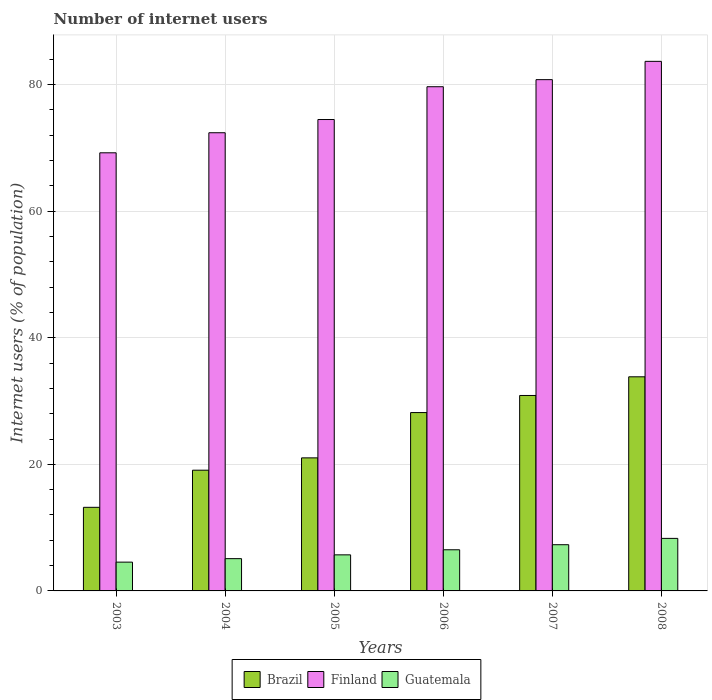How many groups of bars are there?
Your response must be concise. 6. Are the number of bars per tick equal to the number of legend labels?
Give a very brief answer. Yes. How many bars are there on the 5th tick from the left?
Provide a succinct answer. 3. What is the label of the 2nd group of bars from the left?
Your response must be concise. 2004. What is the number of internet users in Finland in 2007?
Give a very brief answer. 80.78. Across all years, what is the maximum number of internet users in Brazil?
Ensure brevity in your answer.  33.83. Across all years, what is the minimum number of internet users in Guatemala?
Offer a very short reply. 4.55. In which year was the number of internet users in Finland maximum?
Keep it short and to the point. 2008. In which year was the number of internet users in Guatemala minimum?
Make the answer very short. 2003. What is the total number of internet users in Finland in the graph?
Your answer should be compact. 460.2. What is the difference between the number of internet users in Finland in 2004 and that in 2006?
Your answer should be compact. -7.27. What is the difference between the number of internet users in Finland in 2003 and the number of internet users in Brazil in 2006?
Your answer should be compact. 41.04. What is the average number of internet users in Guatemala per year?
Offer a very short reply. 6.24. In the year 2008, what is the difference between the number of internet users in Finland and number of internet users in Guatemala?
Provide a short and direct response. 75.37. What is the ratio of the number of internet users in Brazil in 2005 to that in 2008?
Your answer should be very brief. 0.62. Is the number of internet users in Brazil in 2004 less than that in 2008?
Make the answer very short. Yes. Is the difference between the number of internet users in Finland in 2005 and 2008 greater than the difference between the number of internet users in Guatemala in 2005 and 2008?
Provide a short and direct response. No. What is the difference between the highest and the second highest number of internet users in Guatemala?
Make the answer very short. 1. What is the difference between the highest and the lowest number of internet users in Brazil?
Provide a short and direct response. 20.62. In how many years, is the number of internet users in Guatemala greater than the average number of internet users in Guatemala taken over all years?
Your response must be concise. 3. What does the 1st bar from the right in 2005 represents?
Provide a short and direct response. Guatemala. Is it the case that in every year, the sum of the number of internet users in Guatemala and number of internet users in Brazil is greater than the number of internet users in Finland?
Keep it short and to the point. No. How many years are there in the graph?
Your response must be concise. 6. What is the difference between two consecutive major ticks on the Y-axis?
Provide a short and direct response. 20. Are the values on the major ticks of Y-axis written in scientific E-notation?
Provide a short and direct response. No. Does the graph contain any zero values?
Give a very brief answer. No. What is the title of the graph?
Your answer should be compact. Number of internet users. Does "Costa Rica" appear as one of the legend labels in the graph?
Ensure brevity in your answer.  No. What is the label or title of the X-axis?
Provide a short and direct response. Years. What is the label or title of the Y-axis?
Provide a succinct answer. Internet users (% of population). What is the Internet users (% of population) of Brazil in 2003?
Provide a short and direct response. 13.21. What is the Internet users (% of population) in Finland in 2003?
Provide a short and direct response. 69.22. What is the Internet users (% of population) of Guatemala in 2003?
Provide a succinct answer. 4.55. What is the Internet users (% of population) in Brazil in 2004?
Keep it short and to the point. 19.07. What is the Internet users (% of population) in Finland in 2004?
Make the answer very short. 72.39. What is the Internet users (% of population) of Guatemala in 2004?
Your answer should be compact. 5.1. What is the Internet users (% of population) of Brazil in 2005?
Give a very brief answer. 21.02. What is the Internet users (% of population) in Finland in 2005?
Offer a very short reply. 74.48. What is the Internet users (% of population) in Guatemala in 2005?
Keep it short and to the point. 5.7. What is the Internet users (% of population) in Brazil in 2006?
Provide a succinct answer. 28.18. What is the Internet users (% of population) in Finland in 2006?
Ensure brevity in your answer.  79.66. What is the Internet users (% of population) of Brazil in 2007?
Make the answer very short. 30.88. What is the Internet users (% of population) of Finland in 2007?
Your answer should be very brief. 80.78. What is the Internet users (% of population) of Brazil in 2008?
Provide a succinct answer. 33.83. What is the Internet users (% of population) in Finland in 2008?
Keep it short and to the point. 83.67. What is the Internet users (% of population) of Guatemala in 2008?
Your response must be concise. 8.3. Across all years, what is the maximum Internet users (% of population) of Brazil?
Provide a succinct answer. 33.83. Across all years, what is the maximum Internet users (% of population) in Finland?
Ensure brevity in your answer.  83.67. Across all years, what is the minimum Internet users (% of population) of Brazil?
Offer a terse response. 13.21. Across all years, what is the minimum Internet users (% of population) in Finland?
Your answer should be very brief. 69.22. Across all years, what is the minimum Internet users (% of population) of Guatemala?
Ensure brevity in your answer.  4.55. What is the total Internet users (% of population) in Brazil in the graph?
Offer a very short reply. 146.19. What is the total Internet users (% of population) in Finland in the graph?
Give a very brief answer. 460.2. What is the total Internet users (% of population) of Guatemala in the graph?
Offer a very short reply. 37.45. What is the difference between the Internet users (% of population) of Brazil in 2003 and that in 2004?
Keep it short and to the point. -5.87. What is the difference between the Internet users (% of population) of Finland in 2003 and that in 2004?
Provide a succinct answer. -3.17. What is the difference between the Internet users (% of population) of Guatemala in 2003 and that in 2004?
Your answer should be very brief. -0.55. What is the difference between the Internet users (% of population) in Brazil in 2003 and that in 2005?
Give a very brief answer. -7.82. What is the difference between the Internet users (% of population) of Finland in 2003 and that in 2005?
Your answer should be compact. -5.26. What is the difference between the Internet users (% of population) of Guatemala in 2003 and that in 2005?
Your response must be concise. -1.15. What is the difference between the Internet users (% of population) in Brazil in 2003 and that in 2006?
Your answer should be compact. -14.97. What is the difference between the Internet users (% of population) in Finland in 2003 and that in 2006?
Give a very brief answer. -10.44. What is the difference between the Internet users (% of population) of Guatemala in 2003 and that in 2006?
Your response must be concise. -1.95. What is the difference between the Internet users (% of population) of Brazil in 2003 and that in 2007?
Give a very brief answer. -17.67. What is the difference between the Internet users (% of population) in Finland in 2003 and that in 2007?
Your answer should be very brief. -11.56. What is the difference between the Internet users (% of population) in Guatemala in 2003 and that in 2007?
Ensure brevity in your answer.  -2.75. What is the difference between the Internet users (% of population) in Brazil in 2003 and that in 2008?
Ensure brevity in your answer.  -20.62. What is the difference between the Internet users (% of population) in Finland in 2003 and that in 2008?
Offer a terse response. -14.45. What is the difference between the Internet users (% of population) in Guatemala in 2003 and that in 2008?
Ensure brevity in your answer.  -3.75. What is the difference between the Internet users (% of population) of Brazil in 2004 and that in 2005?
Your response must be concise. -1.95. What is the difference between the Internet users (% of population) in Finland in 2004 and that in 2005?
Provide a short and direct response. -2.09. What is the difference between the Internet users (% of population) of Brazil in 2004 and that in 2006?
Offer a terse response. -9.1. What is the difference between the Internet users (% of population) of Finland in 2004 and that in 2006?
Provide a short and direct response. -7.27. What is the difference between the Internet users (% of population) in Brazil in 2004 and that in 2007?
Offer a terse response. -11.81. What is the difference between the Internet users (% of population) in Finland in 2004 and that in 2007?
Ensure brevity in your answer.  -8.39. What is the difference between the Internet users (% of population) in Brazil in 2004 and that in 2008?
Keep it short and to the point. -14.76. What is the difference between the Internet users (% of population) in Finland in 2004 and that in 2008?
Your answer should be compact. -11.28. What is the difference between the Internet users (% of population) in Guatemala in 2004 and that in 2008?
Give a very brief answer. -3.2. What is the difference between the Internet users (% of population) of Brazil in 2005 and that in 2006?
Give a very brief answer. -7.16. What is the difference between the Internet users (% of population) in Finland in 2005 and that in 2006?
Keep it short and to the point. -5.18. What is the difference between the Internet users (% of population) of Brazil in 2005 and that in 2007?
Your answer should be compact. -9.86. What is the difference between the Internet users (% of population) in Brazil in 2005 and that in 2008?
Your response must be concise. -12.81. What is the difference between the Internet users (% of population) in Finland in 2005 and that in 2008?
Offer a very short reply. -9.19. What is the difference between the Internet users (% of population) of Guatemala in 2005 and that in 2008?
Offer a terse response. -2.6. What is the difference between the Internet users (% of population) of Brazil in 2006 and that in 2007?
Offer a terse response. -2.7. What is the difference between the Internet users (% of population) of Finland in 2006 and that in 2007?
Your answer should be compact. -1.12. What is the difference between the Internet users (% of population) in Guatemala in 2006 and that in 2007?
Provide a succinct answer. -0.8. What is the difference between the Internet users (% of population) in Brazil in 2006 and that in 2008?
Offer a terse response. -5.65. What is the difference between the Internet users (% of population) in Finland in 2006 and that in 2008?
Keep it short and to the point. -4.01. What is the difference between the Internet users (% of population) in Guatemala in 2006 and that in 2008?
Ensure brevity in your answer.  -1.8. What is the difference between the Internet users (% of population) in Brazil in 2007 and that in 2008?
Make the answer very short. -2.95. What is the difference between the Internet users (% of population) of Finland in 2007 and that in 2008?
Provide a succinct answer. -2.89. What is the difference between the Internet users (% of population) of Brazil in 2003 and the Internet users (% of population) of Finland in 2004?
Your answer should be compact. -59.18. What is the difference between the Internet users (% of population) of Brazil in 2003 and the Internet users (% of population) of Guatemala in 2004?
Offer a terse response. 8.11. What is the difference between the Internet users (% of population) of Finland in 2003 and the Internet users (% of population) of Guatemala in 2004?
Ensure brevity in your answer.  64.12. What is the difference between the Internet users (% of population) of Brazil in 2003 and the Internet users (% of population) of Finland in 2005?
Your response must be concise. -61.27. What is the difference between the Internet users (% of population) of Brazil in 2003 and the Internet users (% of population) of Guatemala in 2005?
Give a very brief answer. 7.51. What is the difference between the Internet users (% of population) in Finland in 2003 and the Internet users (% of population) in Guatemala in 2005?
Your response must be concise. 63.52. What is the difference between the Internet users (% of population) of Brazil in 2003 and the Internet users (% of population) of Finland in 2006?
Provide a short and direct response. -66.45. What is the difference between the Internet users (% of population) of Brazil in 2003 and the Internet users (% of population) of Guatemala in 2006?
Your answer should be very brief. 6.71. What is the difference between the Internet users (% of population) of Finland in 2003 and the Internet users (% of population) of Guatemala in 2006?
Your answer should be very brief. 62.72. What is the difference between the Internet users (% of population) of Brazil in 2003 and the Internet users (% of population) of Finland in 2007?
Offer a very short reply. -67.57. What is the difference between the Internet users (% of population) in Brazil in 2003 and the Internet users (% of population) in Guatemala in 2007?
Your answer should be very brief. 5.91. What is the difference between the Internet users (% of population) of Finland in 2003 and the Internet users (% of population) of Guatemala in 2007?
Make the answer very short. 61.92. What is the difference between the Internet users (% of population) in Brazil in 2003 and the Internet users (% of population) in Finland in 2008?
Keep it short and to the point. -70.46. What is the difference between the Internet users (% of population) in Brazil in 2003 and the Internet users (% of population) in Guatemala in 2008?
Your answer should be compact. 4.91. What is the difference between the Internet users (% of population) of Finland in 2003 and the Internet users (% of population) of Guatemala in 2008?
Offer a very short reply. 60.92. What is the difference between the Internet users (% of population) of Brazil in 2004 and the Internet users (% of population) of Finland in 2005?
Offer a terse response. -55.41. What is the difference between the Internet users (% of population) of Brazil in 2004 and the Internet users (% of population) of Guatemala in 2005?
Offer a terse response. 13.37. What is the difference between the Internet users (% of population) of Finland in 2004 and the Internet users (% of population) of Guatemala in 2005?
Offer a terse response. 66.69. What is the difference between the Internet users (% of population) of Brazil in 2004 and the Internet users (% of population) of Finland in 2006?
Offer a very short reply. -60.59. What is the difference between the Internet users (% of population) in Brazil in 2004 and the Internet users (% of population) in Guatemala in 2006?
Provide a short and direct response. 12.57. What is the difference between the Internet users (% of population) of Finland in 2004 and the Internet users (% of population) of Guatemala in 2006?
Provide a short and direct response. 65.89. What is the difference between the Internet users (% of population) in Brazil in 2004 and the Internet users (% of population) in Finland in 2007?
Offer a very short reply. -61.71. What is the difference between the Internet users (% of population) of Brazil in 2004 and the Internet users (% of population) of Guatemala in 2007?
Give a very brief answer. 11.77. What is the difference between the Internet users (% of population) of Finland in 2004 and the Internet users (% of population) of Guatemala in 2007?
Give a very brief answer. 65.09. What is the difference between the Internet users (% of population) of Brazil in 2004 and the Internet users (% of population) of Finland in 2008?
Offer a very short reply. -64.6. What is the difference between the Internet users (% of population) in Brazil in 2004 and the Internet users (% of population) in Guatemala in 2008?
Keep it short and to the point. 10.77. What is the difference between the Internet users (% of population) of Finland in 2004 and the Internet users (% of population) of Guatemala in 2008?
Provide a succinct answer. 64.09. What is the difference between the Internet users (% of population) of Brazil in 2005 and the Internet users (% of population) of Finland in 2006?
Make the answer very short. -58.64. What is the difference between the Internet users (% of population) in Brazil in 2005 and the Internet users (% of population) in Guatemala in 2006?
Ensure brevity in your answer.  14.52. What is the difference between the Internet users (% of population) of Finland in 2005 and the Internet users (% of population) of Guatemala in 2006?
Offer a very short reply. 67.98. What is the difference between the Internet users (% of population) of Brazil in 2005 and the Internet users (% of population) of Finland in 2007?
Your answer should be compact. -59.76. What is the difference between the Internet users (% of population) of Brazil in 2005 and the Internet users (% of population) of Guatemala in 2007?
Your answer should be compact. 13.72. What is the difference between the Internet users (% of population) of Finland in 2005 and the Internet users (% of population) of Guatemala in 2007?
Your response must be concise. 67.18. What is the difference between the Internet users (% of population) of Brazil in 2005 and the Internet users (% of population) of Finland in 2008?
Make the answer very short. -62.65. What is the difference between the Internet users (% of population) of Brazil in 2005 and the Internet users (% of population) of Guatemala in 2008?
Keep it short and to the point. 12.72. What is the difference between the Internet users (% of population) in Finland in 2005 and the Internet users (% of population) in Guatemala in 2008?
Make the answer very short. 66.18. What is the difference between the Internet users (% of population) of Brazil in 2006 and the Internet users (% of population) of Finland in 2007?
Offer a very short reply. -52.6. What is the difference between the Internet users (% of population) of Brazil in 2006 and the Internet users (% of population) of Guatemala in 2007?
Give a very brief answer. 20.88. What is the difference between the Internet users (% of population) in Finland in 2006 and the Internet users (% of population) in Guatemala in 2007?
Offer a terse response. 72.36. What is the difference between the Internet users (% of population) of Brazil in 2006 and the Internet users (% of population) of Finland in 2008?
Provide a short and direct response. -55.49. What is the difference between the Internet users (% of population) of Brazil in 2006 and the Internet users (% of population) of Guatemala in 2008?
Give a very brief answer. 19.88. What is the difference between the Internet users (% of population) of Finland in 2006 and the Internet users (% of population) of Guatemala in 2008?
Ensure brevity in your answer.  71.36. What is the difference between the Internet users (% of population) of Brazil in 2007 and the Internet users (% of population) of Finland in 2008?
Offer a terse response. -52.79. What is the difference between the Internet users (% of population) in Brazil in 2007 and the Internet users (% of population) in Guatemala in 2008?
Your answer should be very brief. 22.58. What is the difference between the Internet users (% of population) of Finland in 2007 and the Internet users (% of population) of Guatemala in 2008?
Your response must be concise. 72.48. What is the average Internet users (% of population) of Brazil per year?
Your answer should be compact. 24.37. What is the average Internet users (% of population) of Finland per year?
Offer a very short reply. 76.7. What is the average Internet users (% of population) of Guatemala per year?
Give a very brief answer. 6.24. In the year 2003, what is the difference between the Internet users (% of population) of Brazil and Internet users (% of population) of Finland?
Offer a terse response. -56.01. In the year 2003, what is the difference between the Internet users (% of population) of Brazil and Internet users (% of population) of Guatemala?
Ensure brevity in your answer.  8.66. In the year 2003, what is the difference between the Internet users (% of population) in Finland and Internet users (% of population) in Guatemala?
Offer a terse response. 64.67. In the year 2004, what is the difference between the Internet users (% of population) of Brazil and Internet users (% of population) of Finland?
Ensure brevity in your answer.  -53.32. In the year 2004, what is the difference between the Internet users (% of population) of Brazil and Internet users (% of population) of Guatemala?
Give a very brief answer. 13.97. In the year 2004, what is the difference between the Internet users (% of population) of Finland and Internet users (% of population) of Guatemala?
Your response must be concise. 67.29. In the year 2005, what is the difference between the Internet users (% of population) in Brazil and Internet users (% of population) in Finland?
Offer a terse response. -53.46. In the year 2005, what is the difference between the Internet users (% of population) in Brazil and Internet users (% of population) in Guatemala?
Offer a terse response. 15.32. In the year 2005, what is the difference between the Internet users (% of population) in Finland and Internet users (% of population) in Guatemala?
Provide a succinct answer. 68.78. In the year 2006, what is the difference between the Internet users (% of population) of Brazil and Internet users (% of population) of Finland?
Provide a short and direct response. -51.48. In the year 2006, what is the difference between the Internet users (% of population) of Brazil and Internet users (% of population) of Guatemala?
Your answer should be compact. 21.68. In the year 2006, what is the difference between the Internet users (% of population) of Finland and Internet users (% of population) of Guatemala?
Make the answer very short. 73.16. In the year 2007, what is the difference between the Internet users (% of population) in Brazil and Internet users (% of population) in Finland?
Keep it short and to the point. -49.9. In the year 2007, what is the difference between the Internet users (% of population) in Brazil and Internet users (% of population) in Guatemala?
Offer a very short reply. 23.58. In the year 2007, what is the difference between the Internet users (% of population) in Finland and Internet users (% of population) in Guatemala?
Ensure brevity in your answer.  73.48. In the year 2008, what is the difference between the Internet users (% of population) of Brazil and Internet users (% of population) of Finland?
Give a very brief answer. -49.84. In the year 2008, what is the difference between the Internet users (% of population) of Brazil and Internet users (% of population) of Guatemala?
Offer a very short reply. 25.53. In the year 2008, what is the difference between the Internet users (% of population) in Finland and Internet users (% of population) in Guatemala?
Ensure brevity in your answer.  75.37. What is the ratio of the Internet users (% of population) of Brazil in 2003 to that in 2004?
Keep it short and to the point. 0.69. What is the ratio of the Internet users (% of population) in Finland in 2003 to that in 2004?
Your response must be concise. 0.96. What is the ratio of the Internet users (% of population) of Guatemala in 2003 to that in 2004?
Keep it short and to the point. 0.89. What is the ratio of the Internet users (% of population) of Brazil in 2003 to that in 2005?
Ensure brevity in your answer.  0.63. What is the ratio of the Internet users (% of population) of Finland in 2003 to that in 2005?
Give a very brief answer. 0.93. What is the ratio of the Internet users (% of population) of Guatemala in 2003 to that in 2005?
Make the answer very short. 0.8. What is the ratio of the Internet users (% of population) in Brazil in 2003 to that in 2006?
Provide a succinct answer. 0.47. What is the ratio of the Internet users (% of population) in Finland in 2003 to that in 2006?
Offer a very short reply. 0.87. What is the ratio of the Internet users (% of population) in Guatemala in 2003 to that in 2006?
Make the answer very short. 0.7. What is the ratio of the Internet users (% of population) in Brazil in 2003 to that in 2007?
Your response must be concise. 0.43. What is the ratio of the Internet users (% of population) of Finland in 2003 to that in 2007?
Provide a short and direct response. 0.86. What is the ratio of the Internet users (% of population) of Guatemala in 2003 to that in 2007?
Offer a very short reply. 0.62. What is the ratio of the Internet users (% of population) in Brazil in 2003 to that in 2008?
Make the answer very short. 0.39. What is the ratio of the Internet users (% of population) of Finland in 2003 to that in 2008?
Give a very brief answer. 0.83. What is the ratio of the Internet users (% of population) of Guatemala in 2003 to that in 2008?
Your response must be concise. 0.55. What is the ratio of the Internet users (% of population) in Brazil in 2004 to that in 2005?
Provide a succinct answer. 0.91. What is the ratio of the Internet users (% of population) in Finland in 2004 to that in 2005?
Keep it short and to the point. 0.97. What is the ratio of the Internet users (% of population) in Guatemala in 2004 to that in 2005?
Give a very brief answer. 0.89. What is the ratio of the Internet users (% of population) of Brazil in 2004 to that in 2006?
Provide a succinct answer. 0.68. What is the ratio of the Internet users (% of population) of Finland in 2004 to that in 2006?
Your response must be concise. 0.91. What is the ratio of the Internet users (% of population) of Guatemala in 2004 to that in 2006?
Give a very brief answer. 0.78. What is the ratio of the Internet users (% of population) in Brazil in 2004 to that in 2007?
Provide a short and direct response. 0.62. What is the ratio of the Internet users (% of population) of Finland in 2004 to that in 2007?
Offer a terse response. 0.9. What is the ratio of the Internet users (% of population) in Guatemala in 2004 to that in 2007?
Give a very brief answer. 0.7. What is the ratio of the Internet users (% of population) in Brazil in 2004 to that in 2008?
Ensure brevity in your answer.  0.56. What is the ratio of the Internet users (% of population) in Finland in 2004 to that in 2008?
Give a very brief answer. 0.87. What is the ratio of the Internet users (% of population) of Guatemala in 2004 to that in 2008?
Provide a succinct answer. 0.61. What is the ratio of the Internet users (% of population) in Brazil in 2005 to that in 2006?
Your response must be concise. 0.75. What is the ratio of the Internet users (% of population) in Finland in 2005 to that in 2006?
Provide a short and direct response. 0.94. What is the ratio of the Internet users (% of population) of Guatemala in 2005 to that in 2006?
Your response must be concise. 0.88. What is the ratio of the Internet users (% of population) of Brazil in 2005 to that in 2007?
Provide a short and direct response. 0.68. What is the ratio of the Internet users (% of population) in Finland in 2005 to that in 2007?
Keep it short and to the point. 0.92. What is the ratio of the Internet users (% of population) in Guatemala in 2005 to that in 2007?
Offer a very short reply. 0.78. What is the ratio of the Internet users (% of population) of Brazil in 2005 to that in 2008?
Provide a short and direct response. 0.62. What is the ratio of the Internet users (% of population) of Finland in 2005 to that in 2008?
Offer a very short reply. 0.89. What is the ratio of the Internet users (% of population) in Guatemala in 2005 to that in 2008?
Offer a very short reply. 0.69. What is the ratio of the Internet users (% of population) of Brazil in 2006 to that in 2007?
Provide a short and direct response. 0.91. What is the ratio of the Internet users (% of population) of Finland in 2006 to that in 2007?
Provide a short and direct response. 0.99. What is the ratio of the Internet users (% of population) in Guatemala in 2006 to that in 2007?
Offer a terse response. 0.89. What is the ratio of the Internet users (% of population) of Brazil in 2006 to that in 2008?
Ensure brevity in your answer.  0.83. What is the ratio of the Internet users (% of population) in Finland in 2006 to that in 2008?
Provide a short and direct response. 0.95. What is the ratio of the Internet users (% of population) in Guatemala in 2006 to that in 2008?
Provide a succinct answer. 0.78. What is the ratio of the Internet users (% of population) of Brazil in 2007 to that in 2008?
Offer a terse response. 0.91. What is the ratio of the Internet users (% of population) in Finland in 2007 to that in 2008?
Ensure brevity in your answer.  0.97. What is the ratio of the Internet users (% of population) of Guatemala in 2007 to that in 2008?
Provide a succinct answer. 0.88. What is the difference between the highest and the second highest Internet users (% of population) of Brazil?
Make the answer very short. 2.95. What is the difference between the highest and the second highest Internet users (% of population) in Finland?
Your response must be concise. 2.89. What is the difference between the highest and the second highest Internet users (% of population) of Guatemala?
Make the answer very short. 1. What is the difference between the highest and the lowest Internet users (% of population) in Brazil?
Your answer should be compact. 20.62. What is the difference between the highest and the lowest Internet users (% of population) of Finland?
Give a very brief answer. 14.45. What is the difference between the highest and the lowest Internet users (% of population) of Guatemala?
Offer a very short reply. 3.75. 